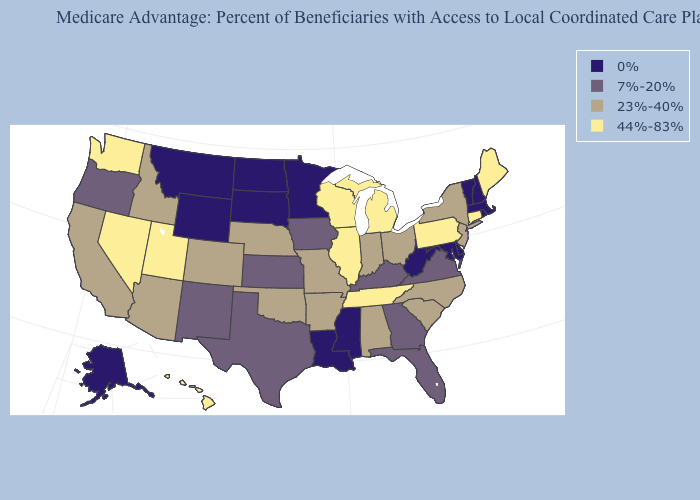Does Louisiana have a lower value than South Dakota?
Be succinct. No. Among the states that border New Jersey , does Delaware have the highest value?
Write a very short answer. No. What is the highest value in the USA?
Answer briefly. 44%-83%. What is the lowest value in the USA?
Be succinct. 0%. Does the first symbol in the legend represent the smallest category?
Quick response, please. Yes. Which states have the lowest value in the USA?
Give a very brief answer. Alaska, Delaware, Louisiana, Massachusetts, Maryland, Minnesota, Mississippi, Montana, North Dakota, New Hampshire, Rhode Island, South Dakota, Vermont, West Virginia, Wyoming. Among the states that border Indiana , does Michigan have the lowest value?
Be succinct. No. Does Wisconsin have the highest value in the USA?
Write a very short answer. Yes. What is the value of Arizona?
Write a very short answer. 23%-40%. Does Wisconsin have a higher value than California?
Keep it brief. Yes. Does the first symbol in the legend represent the smallest category?
Short answer required. Yes. What is the value of Nevada?
Keep it brief. 44%-83%. What is the value of Montana?
Give a very brief answer. 0%. Does Arkansas have the highest value in the USA?
Quick response, please. No. 